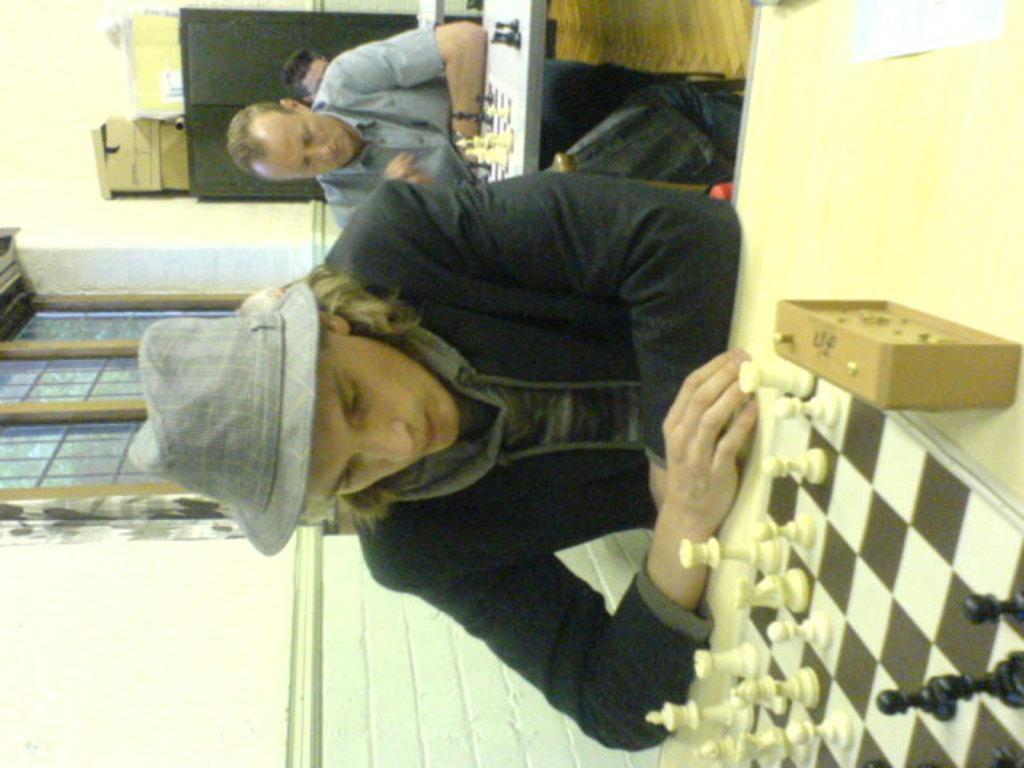In one or two sentences, can you explain what this image depicts? In this image we can see three persons sitting and playing the chess, on the left side of the image we can see the wall and window, in the background we can see a cupboard with some objects on it. 